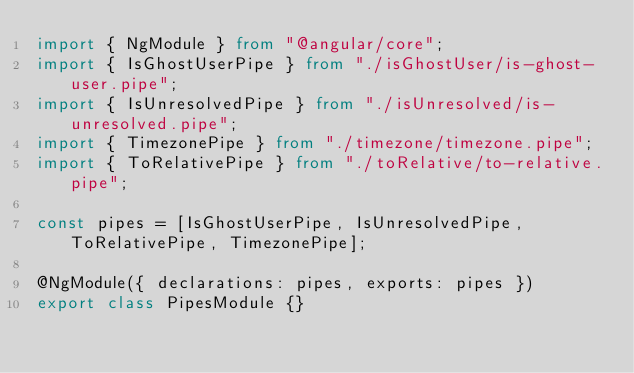<code> <loc_0><loc_0><loc_500><loc_500><_TypeScript_>import { NgModule } from "@angular/core";
import { IsGhostUserPipe } from "./isGhostUser/is-ghost-user.pipe";
import { IsUnresolvedPipe } from "./isUnresolved/is-unresolved.pipe";
import { TimezonePipe } from "./timezone/timezone.pipe";
import { ToRelativePipe } from "./toRelative/to-relative.pipe";

const pipes = [IsGhostUserPipe, IsUnresolvedPipe, ToRelativePipe, TimezonePipe];

@NgModule({ declarations: pipes, exports: pipes })
export class PipesModule {}
</code> 